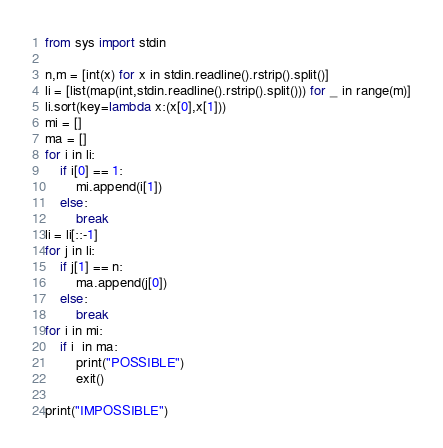Convert code to text. <code><loc_0><loc_0><loc_500><loc_500><_Python_>from sys import stdin

n,m = [int(x) for x in stdin.readline().rstrip().split()]
li = [list(map(int,stdin.readline().rstrip().split())) for _ in range(m)]
li.sort(key=lambda x:(x[0],x[1]))
mi = []
ma = []
for i in li:
    if i[0] == 1:
        mi.append(i[1])
    else:
        break
li = li[::-1]
for j in li:
    if j[1] == n:
        ma.append(j[0])
    else:
        break
for i in mi:
    if i  in ma:
        print("POSSIBLE")
        exit()

print("IMPOSSIBLE")</code> 